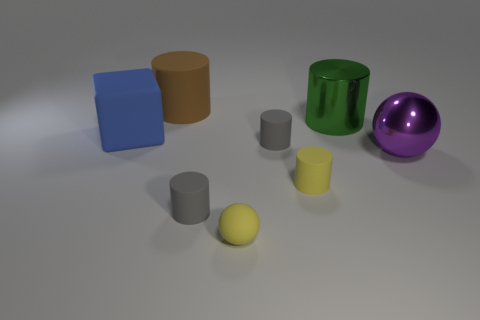What number of gray objects are big rubber cubes or shiny cylinders?
Your answer should be very brief. 0. The small sphere has what color?
Provide a short and direct response. Yellow. Are there fewer purple shiny spheres to the right of the big green cylinder than cylinders in front of the big block?
Offer a very short reply. Yes. There is a big object that is both left of the yellow rubber cylinder and to the right of the blue block; what shape is it?
Give a very brief answer. Cylinder. What number of other big metal things are the same shape as the large purple thing?
Your answer should be very brief. 0. What size is the purple ball that is made of the same material as the big green object?
Provide a succinct answer. Large. What number of yellow things are the same size as the yellow matte cylinder?
Make the answer very short. 1. What color is the thing that is left of the rubber cylinder that is behind the big rubber block?
Keep it short and to the point. Blue. Are there any small rubber cylinders that have the same color as the block?
Ensure brevity in your answer.  No. The metallic cylinder that is the same size as the blue cube is what color?
Give a very brief answer. Green. 